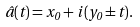<formula> <loc_0><loc_0><loc_500><loc_500>\hat { a } ( t ) = x _ { 0 } + i \, ( y _ { 0 } \pm t ) .</formula> 